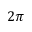<formula> <loc_0><loc_0><loc_500><loc_500>2 \pi</formula> 